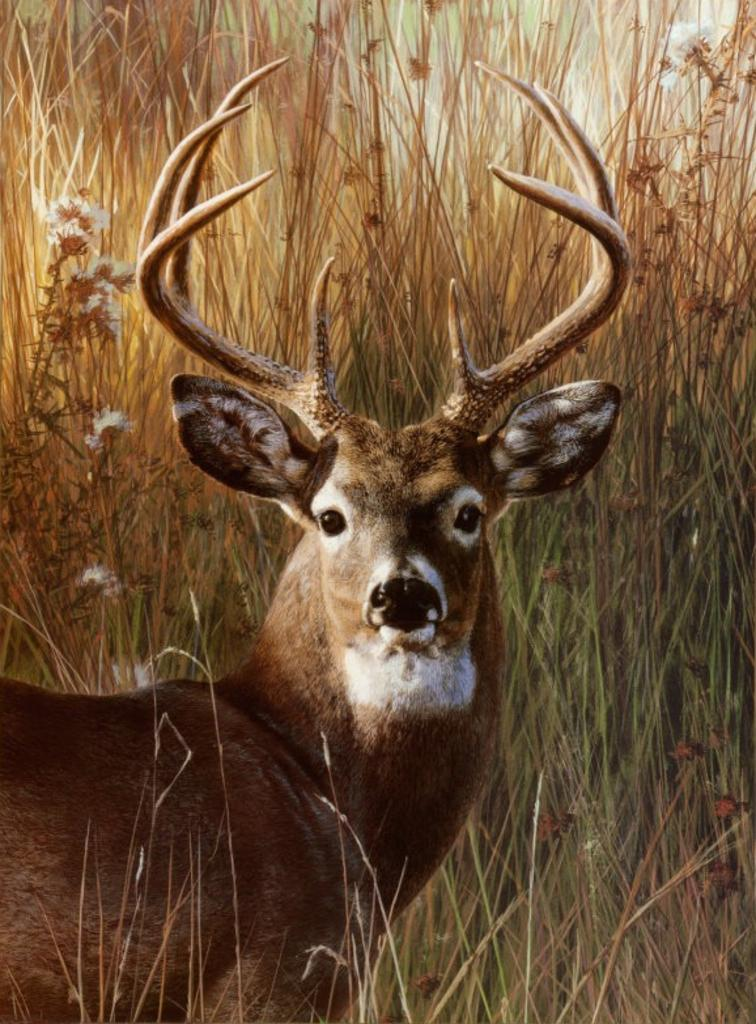What animal is present in the image? There is a deer in the image. What distinguishing feature does the deer have? The deer has horns on its head. Where is the deer located in the image? The deer is standing on the ground. What can be seen in the background of the image? There is a group of plants in the background of the image. How many beds can be seen in the image? There are no beds present in the image; it features a deer with horns standing on the ground. 